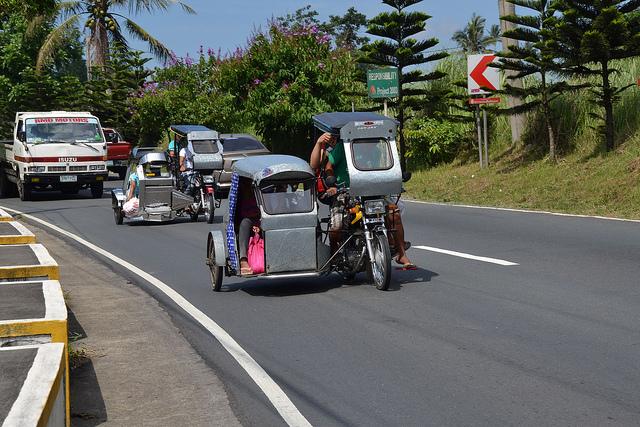How many lights are on the front of the motorcycle?
Concise answer only. 1. How many bikes are shown?
Be succinct. 2. Is this photo taken in the United States?
Write a very short answer. No. Which way do the red arrows point?
Keep it brief. Left. 